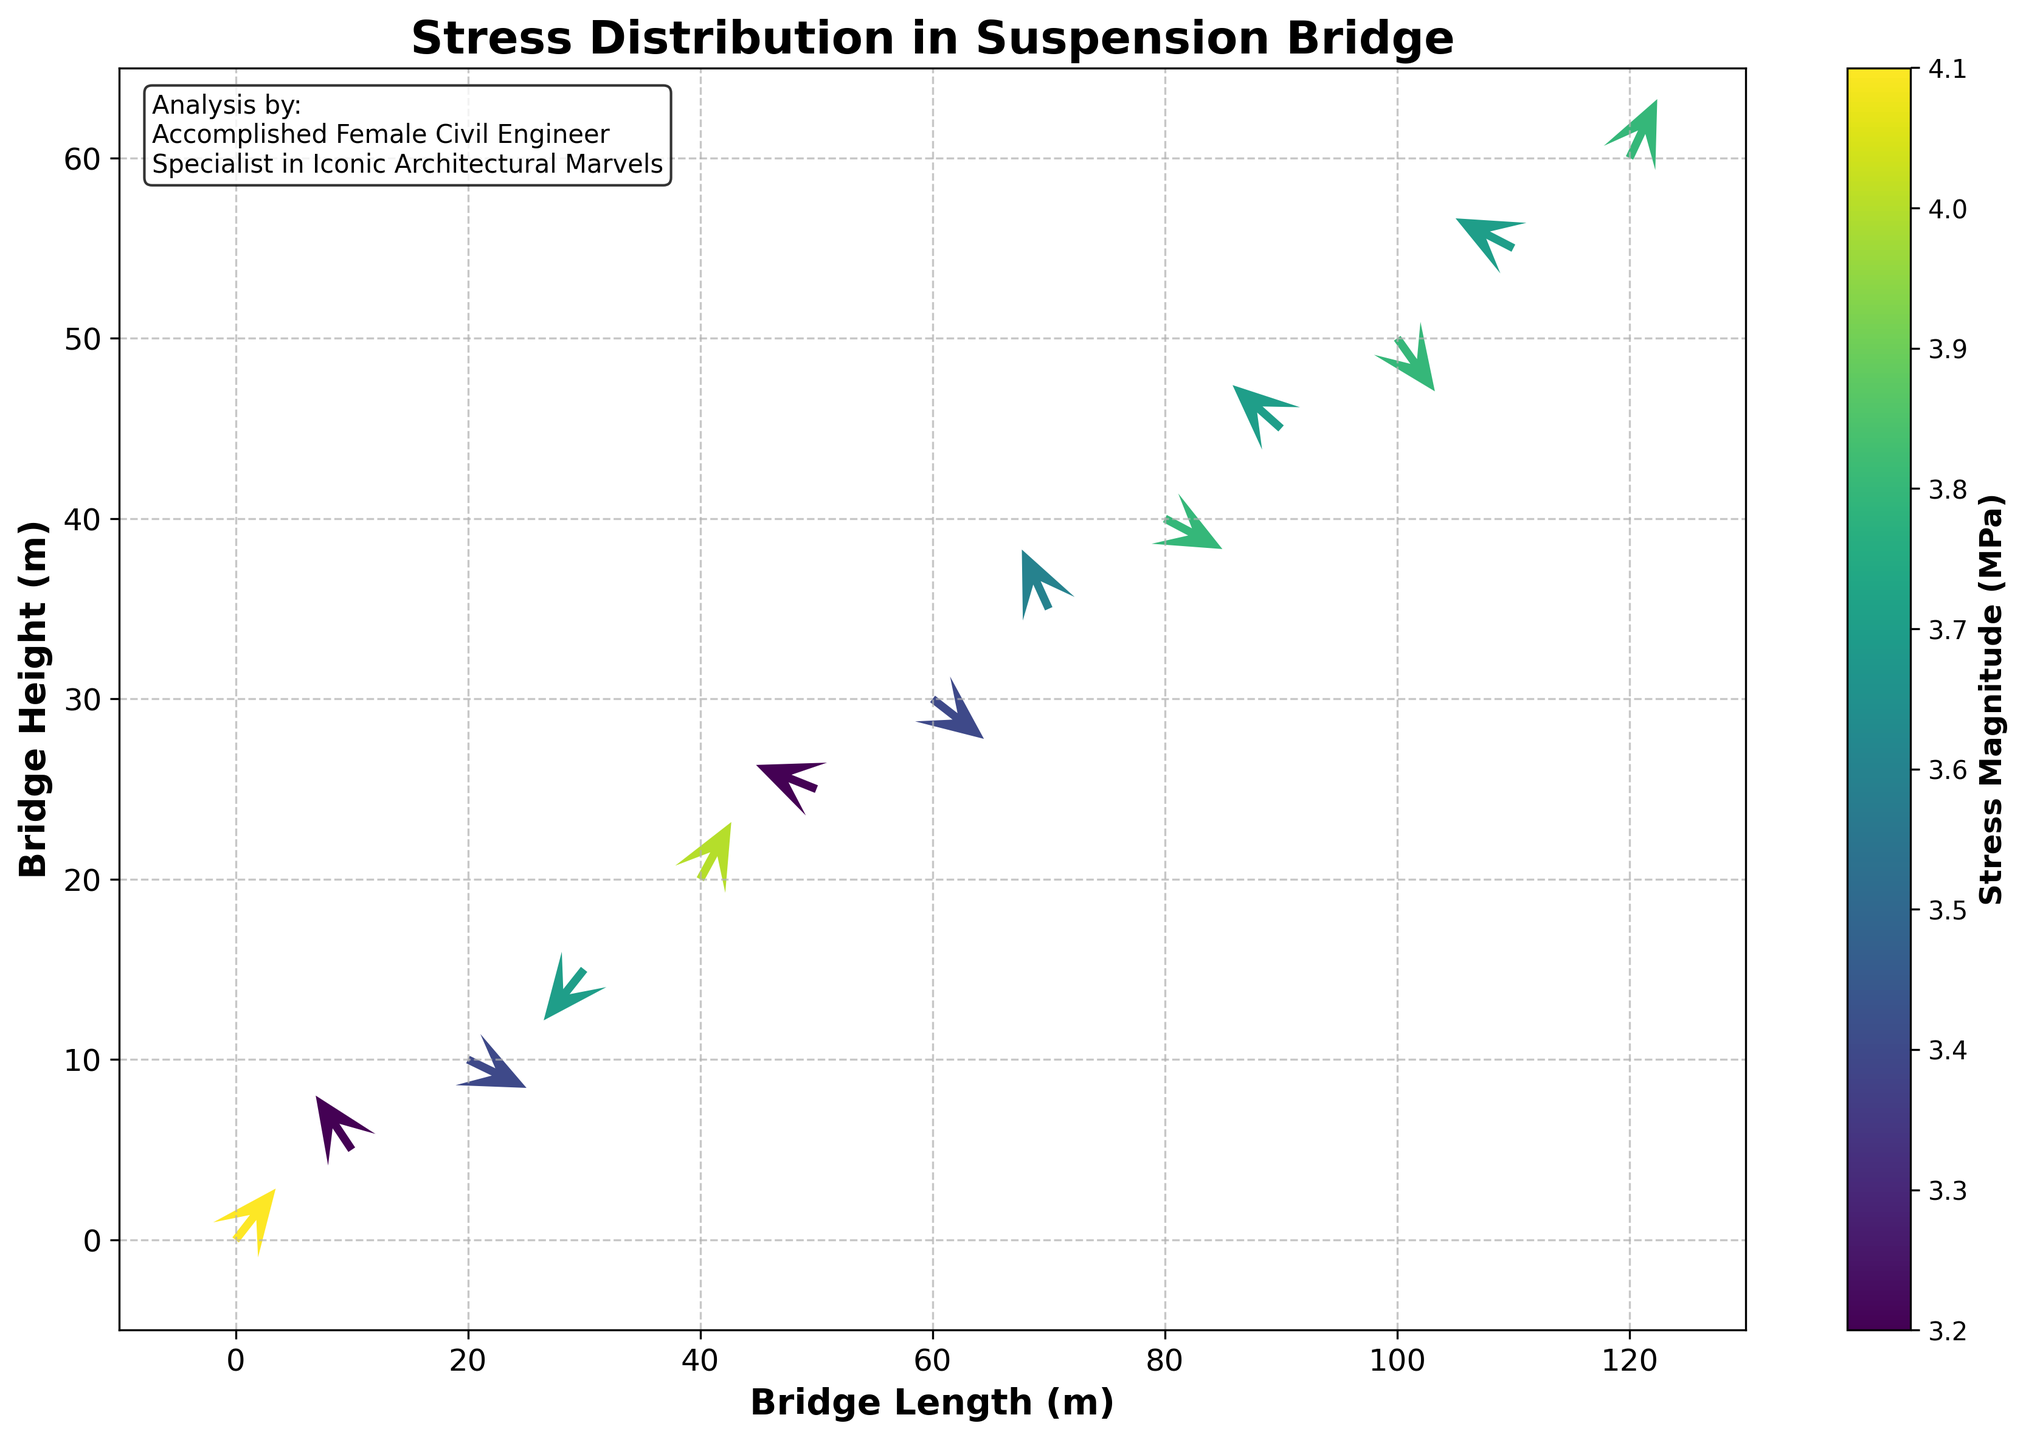What is the title of the plot? The title of the plot is located at the top of the figure. It is typically a concise description of what the plot represents. In this case, it states "Stress Distribution in Suspension Bridge".
Answer: Stress Distribution in Suspension Bridge What do the colors in the plot represent? The colors in the plot represent the stress magnitude in MPa. The colorbar on the right side of the plot explains this, showing the range of values and their corresponding colors.
Answer: Stress Magnitude (MPa) How many vectors are used to represent the stress distribution in the plot? Count the number of arrow-origin points (x, y coordinates) to determine the number of vectors. There are coordinates given at 13 different positions, meaning there are 13 vectors.
Answer: 13 Which axis represents the bridge height? The y-axis label confirms this by stating "Bridge Height (m)". This suggests the height of the suspension bridge is represented on this axis.
Answer: y-axis What are the minimum and maximum bridge lengths represented in the plot? The x-axis represents the bridge length. The axis ranges from -10 meters to 130 meters.
Answer: -10 meters and 130 meters Which vector shows the highest stress magnitude? By examining the color intensity on the vectors, the vector where the magnitude is highest can be identified. The figure’s colorbar indicates that the vector with the most intense color (at (0, 0)) has the highest magnitude of 4.1 MPa.
Answer: Vector at (0, 0) Compare the vectors at coordinates (50, 25) and (60, 30). Which has a higher counterclockwise rotation? To determine the counterclockwise rotation, analyze the angle of the vectors relative to the horizontal axis. The vector at (60, 30) is closer to a negative y-direction indicating a steeper counterclockwise rotation compared to (50, 25).
Answer: Vector at (60, 30) What is the average magnitude of stress for the vectors at (20, 10), (40, 20), and (60, 30)? Identify magnitudes at the specified points: 3.4, 4.0, and 3.4, respectively. Sum these values (3.4 + 4.0 + 3.4 = 10.8) and divide by 3.
Answer: 3.6 MPa Are there more vectors pointing predominantly upwards or downwards? By examining the direction of each vector: upwards (positive v values) for 7 vectors; downwards (negative v values) for 6 vectors.
Answer: More vectors pointing upwards (7) Which vector is pointing as much to the left in the x-direction as to the right? Identifying the vectors with equal magnitude in the positive and negative u directions shows the vector at (0, 0) points to the right (+2.5) and (40, 20) to the left (-2.3). No vectors split evenly but (40, 20) is closest at -2.3.
Answer: Vector at (40, 20) 